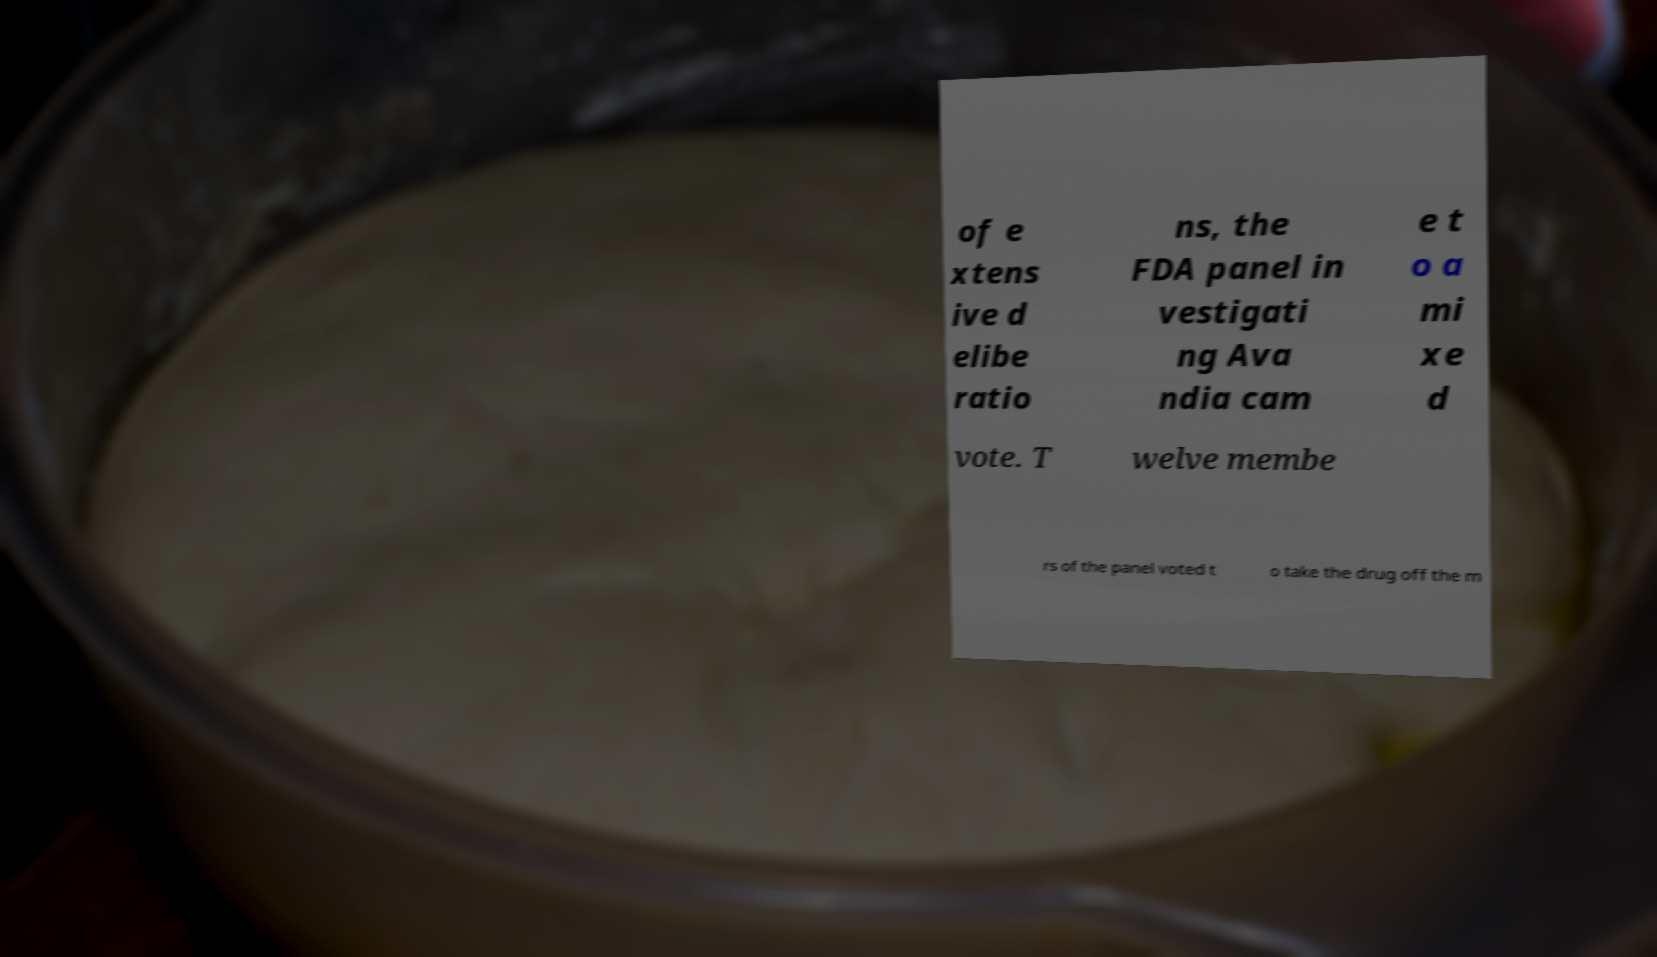For documentation purposes, I need the text within this image transcribed. Could you provide that? of e xtens ive d elibe ratio ns, the FDA panel in vestigati ng Ava ndia cam e t o a mi xe d vote. T welve membe rs of the panel voted t o take the drug off the m 